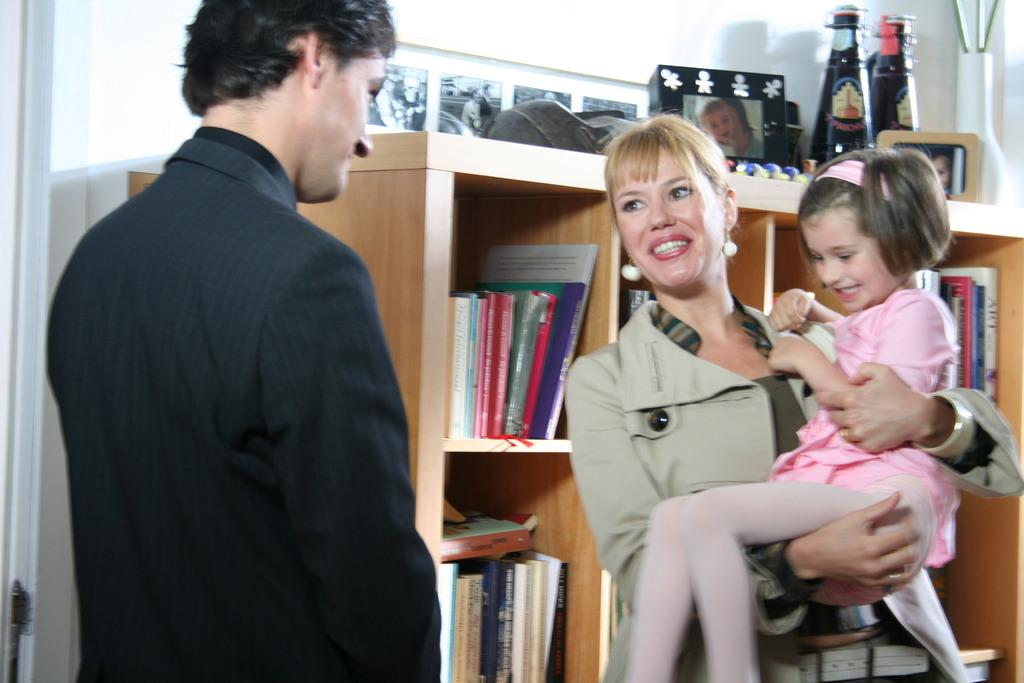How many people are present in the image? There are three people in the image: a man, a woman, and a girl. What is the relationship between the woman and the girl in the image? The girl is being held by the woman. What expressions do the woman and the girl have in the image? The woman and the girl are both smiling. What can be seen in the background of the image? There is a bookshelf and a wall in the background of the image. How many cubs are playing with bikes in the image? There are no cubs or bikes present in the image. What type of quartz can be seen on the wall in the image? There is no quartz visible on the wall in the image. 